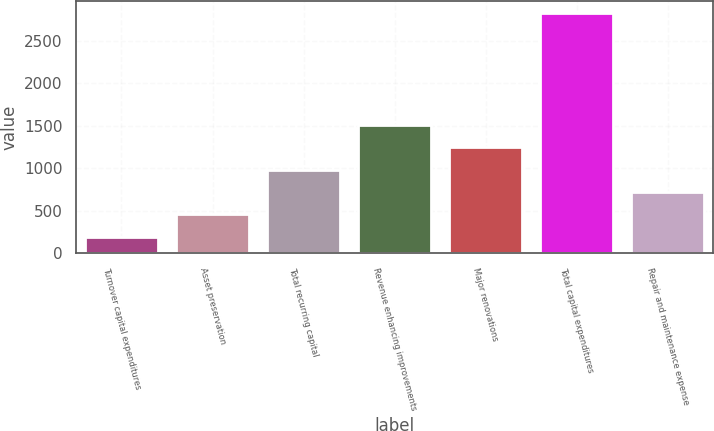Convert chart to OTSL. <chart><loc_0><loc_0><loc_500><loc_500><bar_chart><fcel>Turnover capital expenditures<fcel>Asset preservation<fcel>Total recurring capital<fcel>Revenue enhancing improvements<fcel>Major renovations<fcel>Total capital expenditures<fcel>Repair and maintenance expense<nl><fcel>194<fcel>457.5<fcel>984.5<fcel>1511.5<fcel>1248<fcel>2829<fcel>721<nl></chart> 